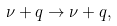Convert formula to latex. <formula><loc_0><loc_0><loc_500><loc_500>\nu + q \rightarrow \nu + q ,</formula> 